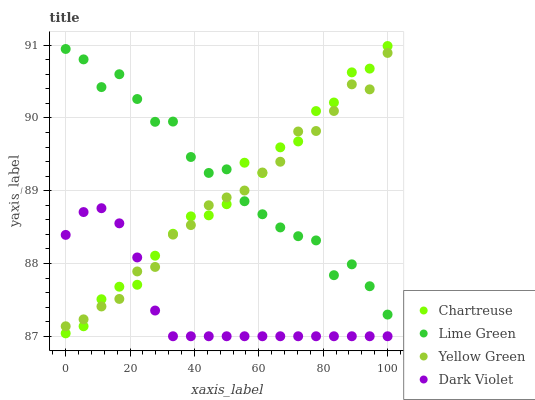Does Dark Violet have the minimum area under the curve?
Answer yes or no. Yes. Does Lime Green have the maximum area under the curve?
Answer yes or no. Yes. Does Yellow Green have the minimum area under the curve?
Answer yes or no. No. Does Yellow Green have the maximum area under the curve?
Answer yes or no. No. Is Dark Violet the smoothest?
Answer yes or no. Yes. Is Lime Green the roughest?
Answer yes or no. Yes. Is Yellow Green the smoothest?
Answer yes or no. No. Is Yellow Green the roughest?
Answer yes or no. No. Does Dark Violet have the lowest value?
Answer yes or no. Yes. Does Yellow Green have the lowest value?
Answer yes or no. No. Does Chartreuse have the highest value?
Answer yes or no. Yes. Does Lime Green have the highest value?
Answer yes or no. No. Is Dark Violet less than Lime Green?
Answer yes or no. Yes. Is Lime Green greater than Dark Violet?
Answer yes or no. Yes. Does Chartreuse intersect Lime Green?
Answer yes or no. Yes. Is Chartreuse less than Lime Green?
Answer yes or no. No. Is Chartreuse greater than Lime Green?
Answer yes or no. No. Does Dark Violet intersect Lime Green?
Answer yes or no. No. 